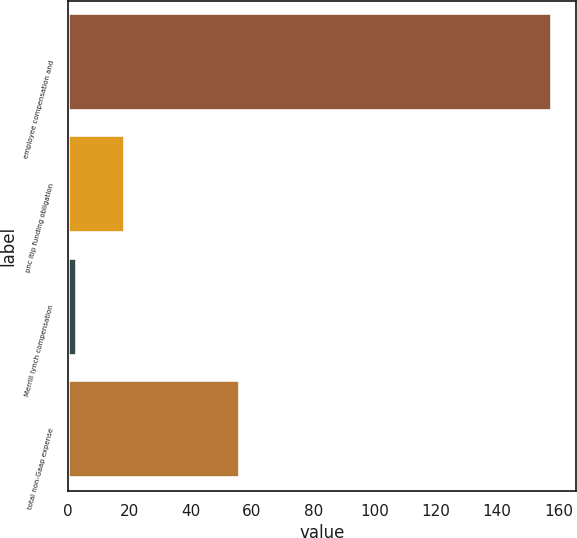<chart> <loc_0><loc_0><loc_500><loc_500><bar_chart><fcel>employee compensation and<fcel>pnc ltip funding obligation<fcel>Merrill lynch compensation<fcel>total non-Gaap expense<nl><fcel>158<fcel>18.5<fcel>3<fcel>56<nl></chart> 